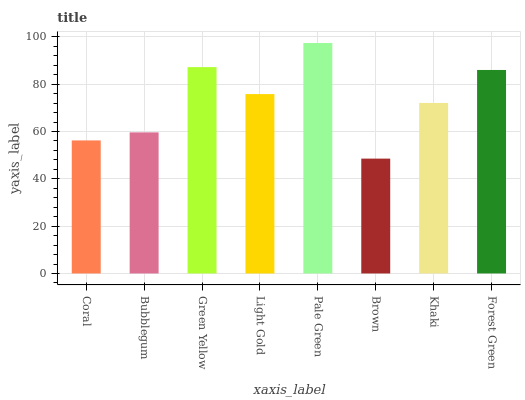Is Brown the minimum?
Answer yes or no. Yes. Is Pale Green the maximum?
Answer yes or no. Yes. Is Bubblegum the minimum?
Answer yes or no. No. Is Bubblegum the maximum?
Answer yes or no. No. Is Bubblegum greater than Coral?
Answer yes or no. Yes. Is Coral less than Bubblegum?
Answer yes or no. Yes. Is Coral greater than Bubblegum?
Answer yes or no. No. Is Bubblegum less than Coral?
Answer yes or no. No. Is Light Gold the high median?
Answer yes or no. Yes. Is Khaki the low median?
Answer yes or no. Yes. Is Pale Green the high median?
Answer yes or no. No. Is Forest Green the low median?
Answer yes or no. No. 